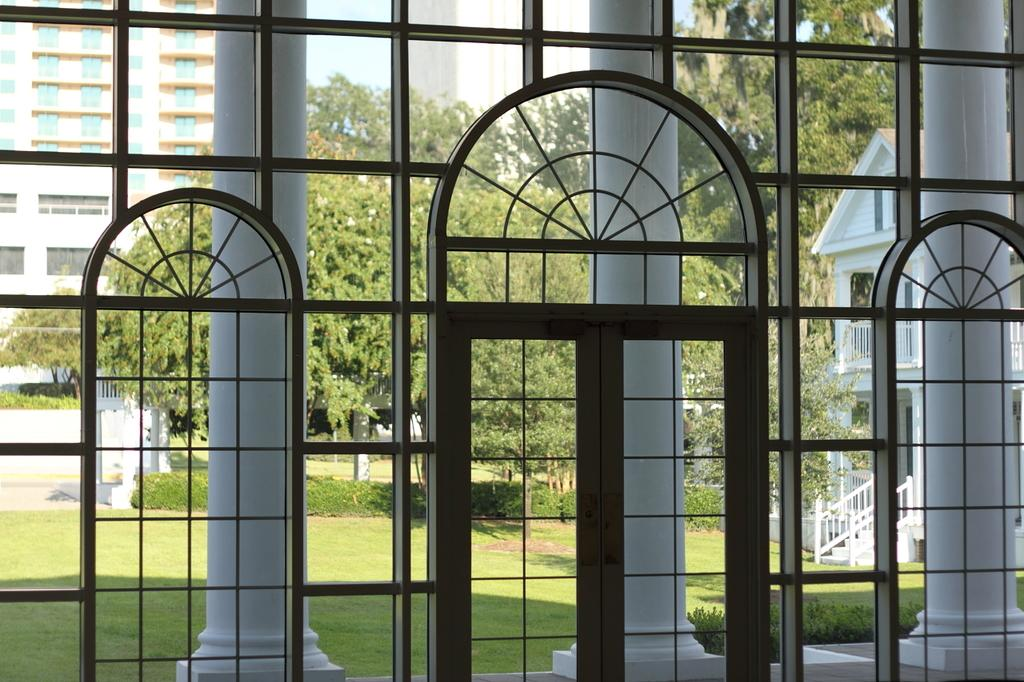What type of doors can be seen in the image? There are glass doors in the image. What type of structure is visible in the image? There is a house in the image. What architectural feature is present in the image? There are stairs in the image. What other structures can be seen in the image? There are buildings in the image. What can be seen on the house in the image? There are windows in the image. What type of natural environment is visible in the image? There is grass, plants, and trees in the image. What type of barrier is present in the image? There is a fence in the image. What is visible in the sky in the image? The sky is visible in the image. How many bikes are parked near the house in the image? There are no bikes present in the image. Can you see a crown on top of the house in the image? There is no crown present in the image. 